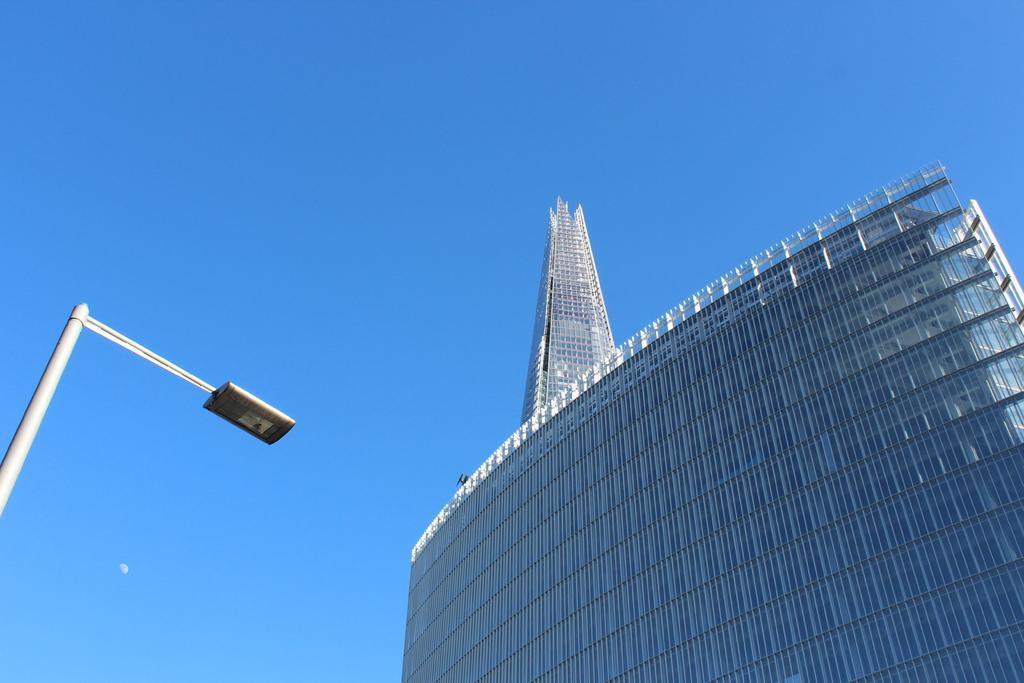What type of structure is present in the image? There is a building in the image. What material is the building made of? The building is made up of glass. What other object can be seen in the image? There is a light pole in the image. What is the color of the sky in the image? The sky is blue in the image. What celestial object is visible in the image? There is a half moon visible in the image. Where is the crown placed on the building in the image? There is no crown present on the building in the image. What type of lamp is used to illuminate the area around the building in the image? There is no lamp mentioned in the image; only a light pole is visible. 